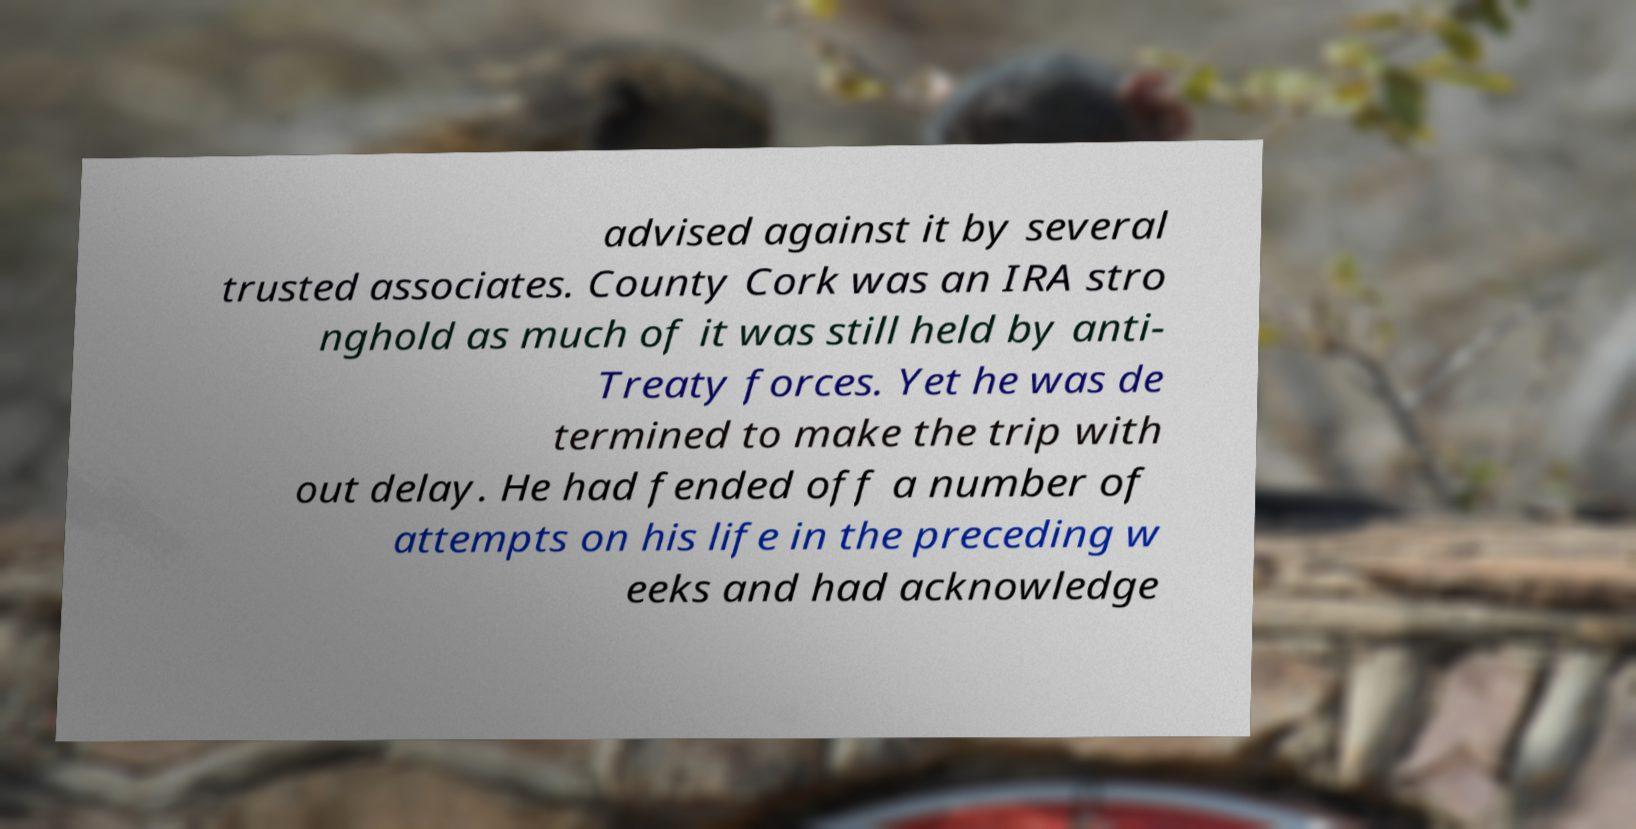I need the written content from this picture converted into text. Can you do that? advised against it by several trusted associates. County Cork was an IRA stro nghold as much of it was still held by anti- Treaty forces. Yet he was de termined to make the trip with out delay. He had fended off a number of attempts on his life in the preceding w eeks and had acknowledge 